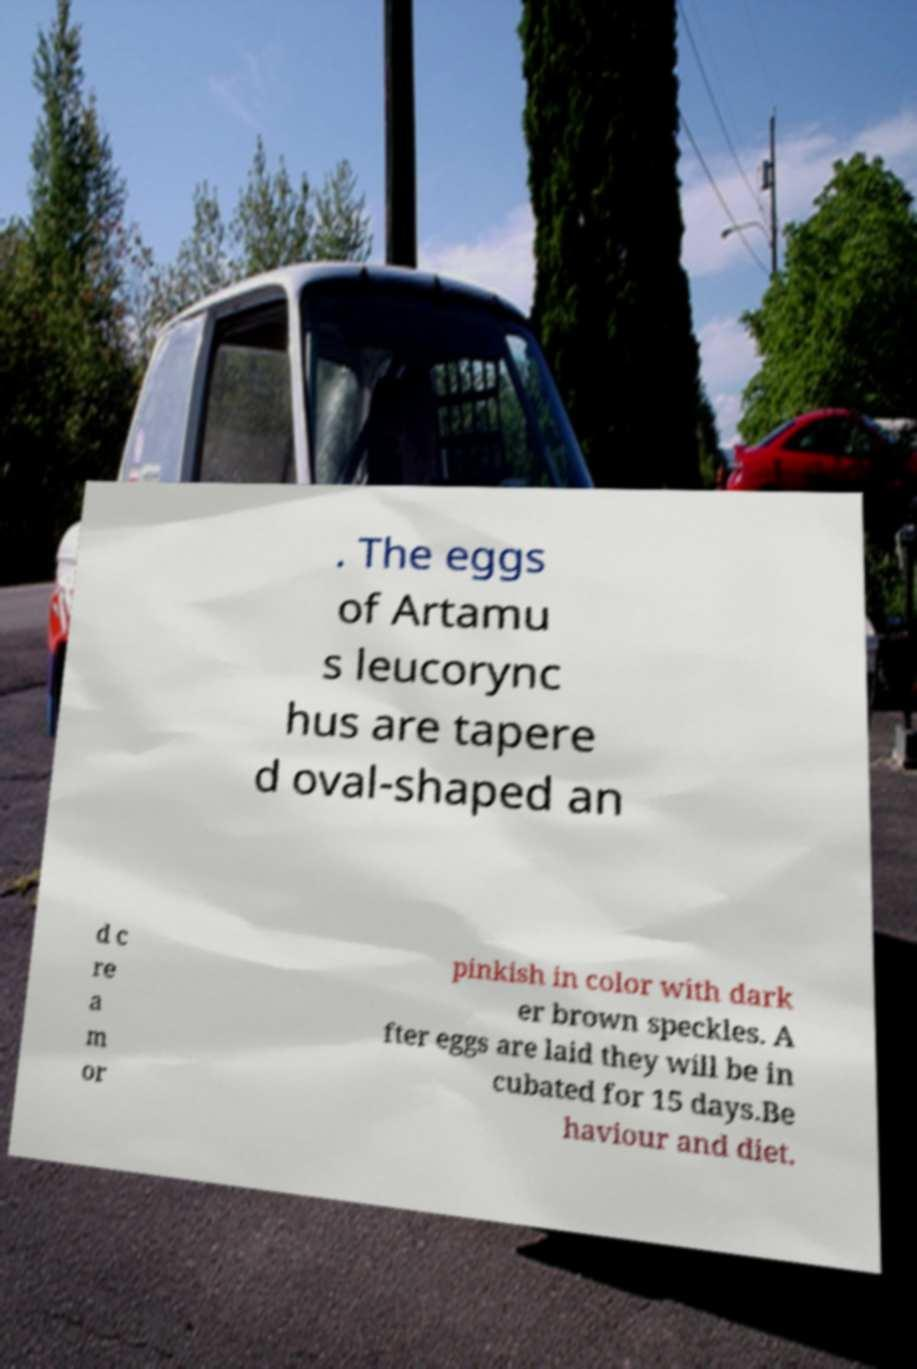For documentation purposes, I need the text within this image transcribed. Could you provide that? . The eggs of Artamu s leucorync hus are tapere d oval-shaped an d c re a m or pinkish in color with dark er brown speckles. A fter eggs are laid they will be in cubated for 15 days.Be haviour and diet. 